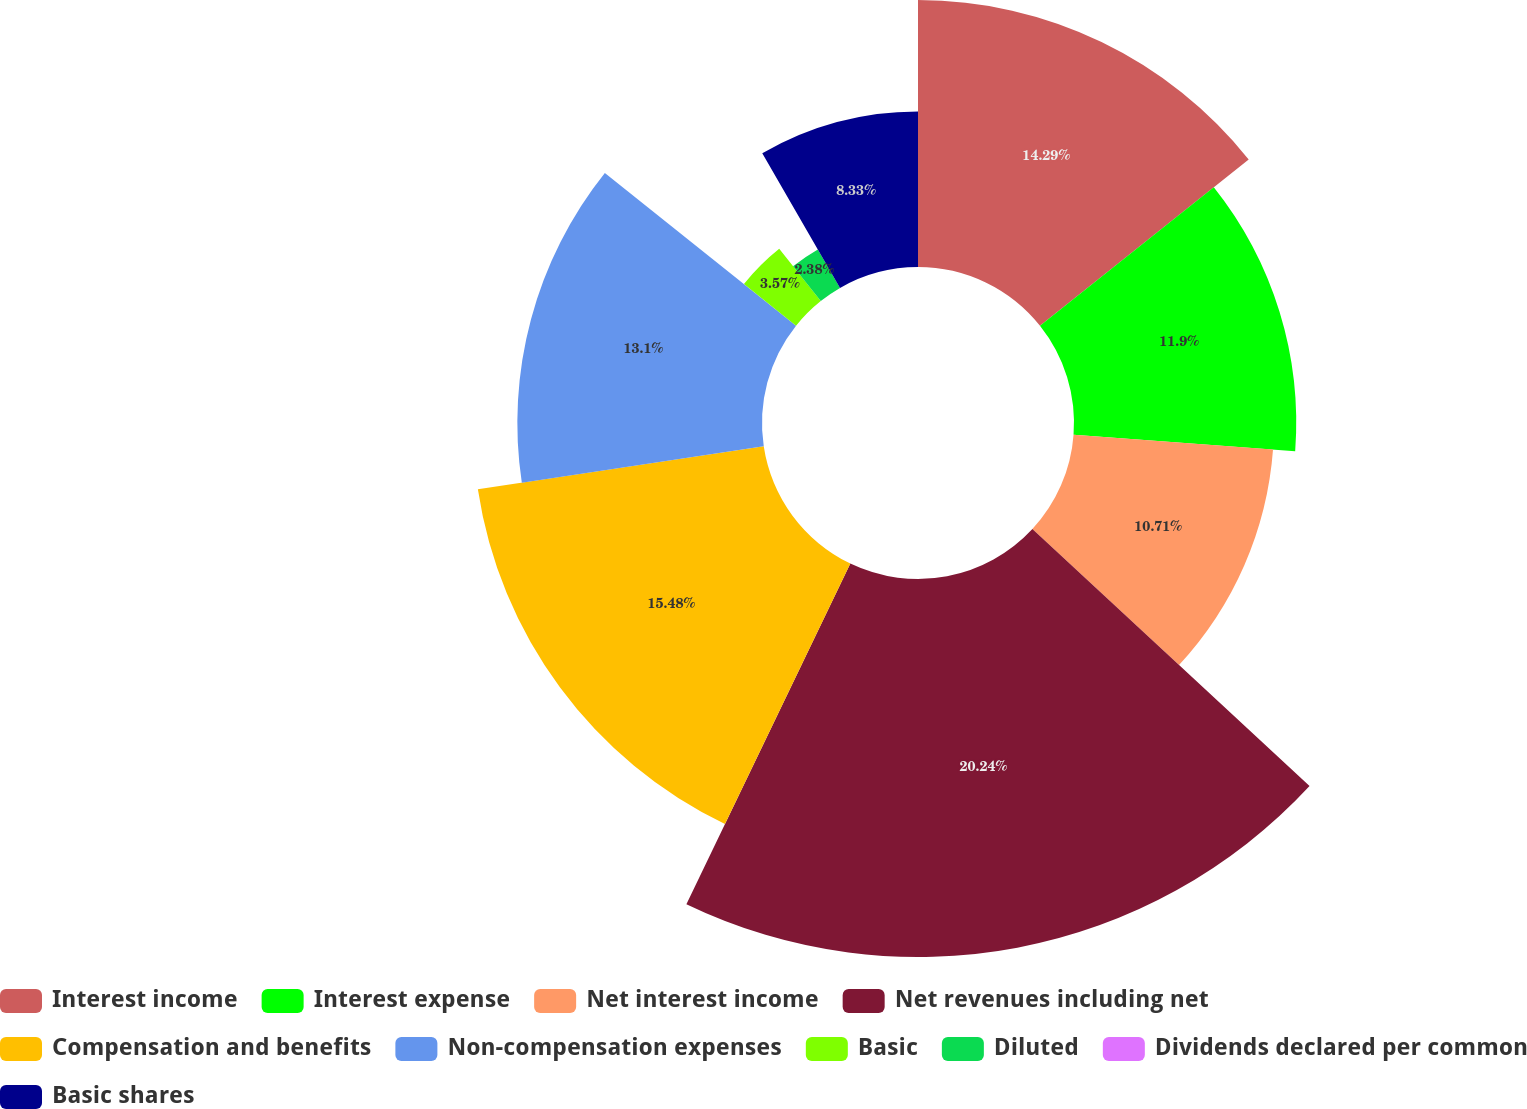Convert chart. <chart><loc_0><loc_0><loc_500><loc_500><pie_chart><fcel>Interest income<fcel>Interest expense<fcel>Net interest income<fcel>Net revenues including net<fcel>Compensation and benefits<fcel>Non-compensation expenses<fcel>Basic<fcel>Diluted<fcel>Dividends declared per common<fcel>Basic shares<nl><fcel>14.29%<fcel>11.9%<fcel>10.71%<fcel>20.24%<fcel>15.48%<fcel>13.1%<fcel>3.57%<fcel>2.38%<fcel>0.0%<fcel>8.33%<nl></chart> 